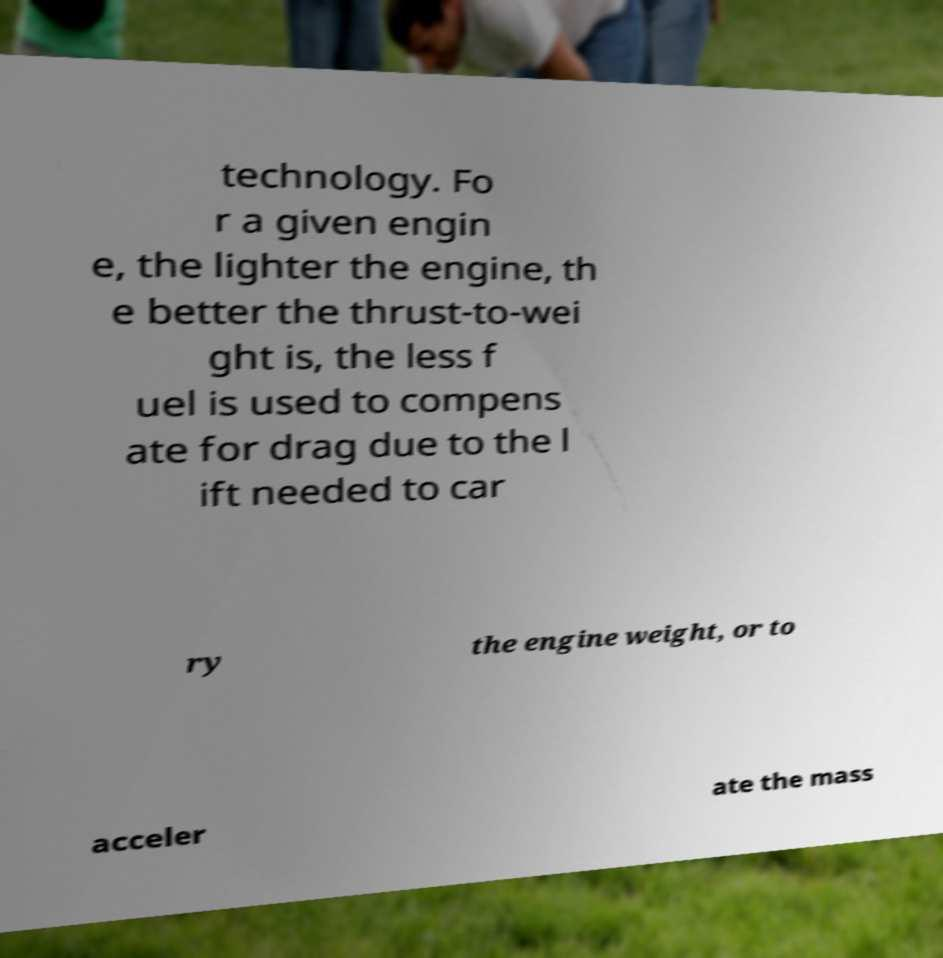Could you extract and type out the text from this image? technology. Fo r a given engin e, the lighter the engine, th e better the thrust-to-wei ght is, the less f uel is used to compens ate for drag due to the l ift needed to car ry the engine weight, or to acceler ate the mass 